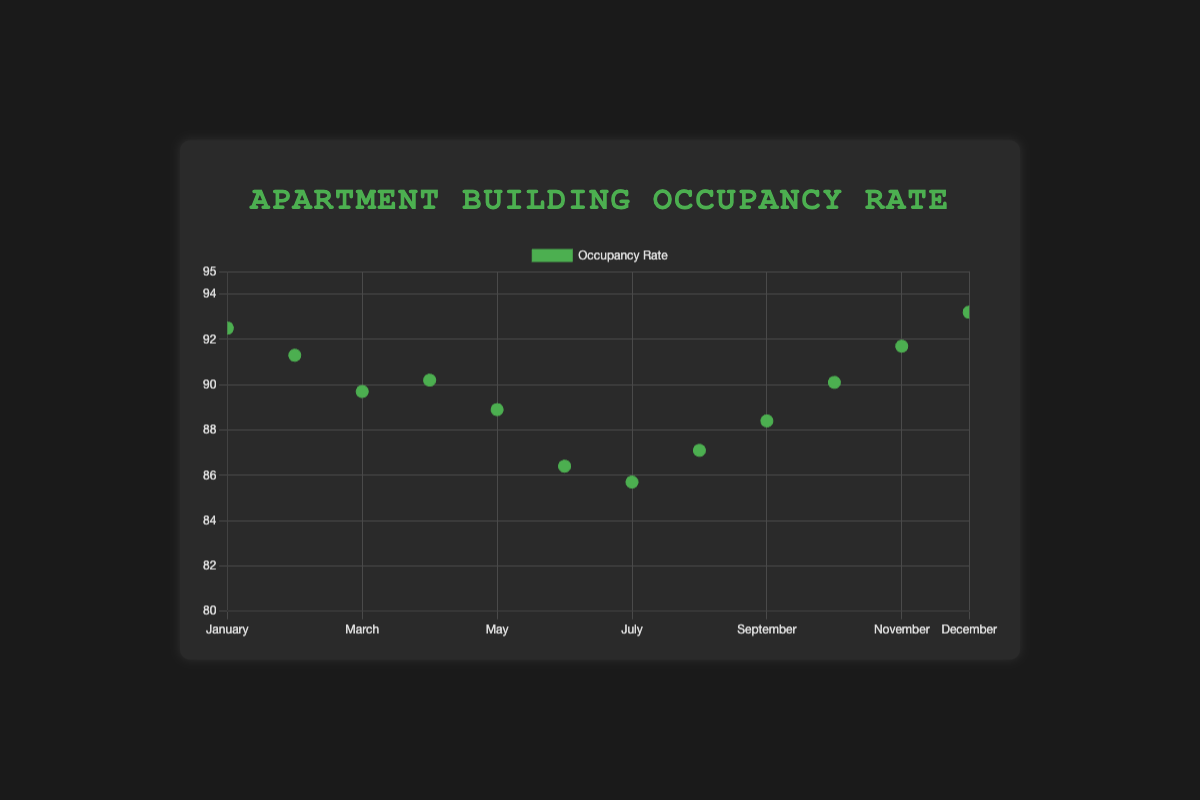What's the title of the chart? The chart title is prominently displayed at the top and reads "Apartment Building Occupancy Rate"
Answer: Apartment Building Occupancy Rate How many data points are plotted in the chart? Each month from January to December has one data point plotted, resulting in 12 data points
Answer: 12 What's the occupancy rate in February? By visually inspecting the dot corresponding to February, the y-axis value for February is 91.3%
Answer: 91.3% Which month has the highest occupancy rate? The highest dot on the y-axis corresponds to December with an occupancy rate of 93.2%
Answer: December How does the occupancy rate change from January to June? The occupancy rates decrease month by month starting from January (92.5%) to June (86.4%), showing a downward trend
Answer: Decreases What is the difference in occupancy rates between March and October? March has an occupancy rate of 89.7%, and October has 90.1%, so the difference is 90.1% - 89.7% = 0.4%
Answer: 0.4% What is the average occupancy rate for April, May, and June? Adding the occupancy rates of April (90.2%), May (88.9%), and June (86.4%) and then dividing by 3: (90.2 + 88.9 + 86.4)/3 = 88.5%
Answer: 88.5% Which months have an occupancy rate greater than 90%? The months with dots above the 90% mark on the y-axis are January, February, October, November, and December
Answer: January, February, October, November, December Is there a general trend in occupancy rates throughout the year? Observing the data points connected by the trend line, the occupancy rate generally decreases from the beginning to the middle of the year and then increases again towards the end
Answer: Decreases then increases 